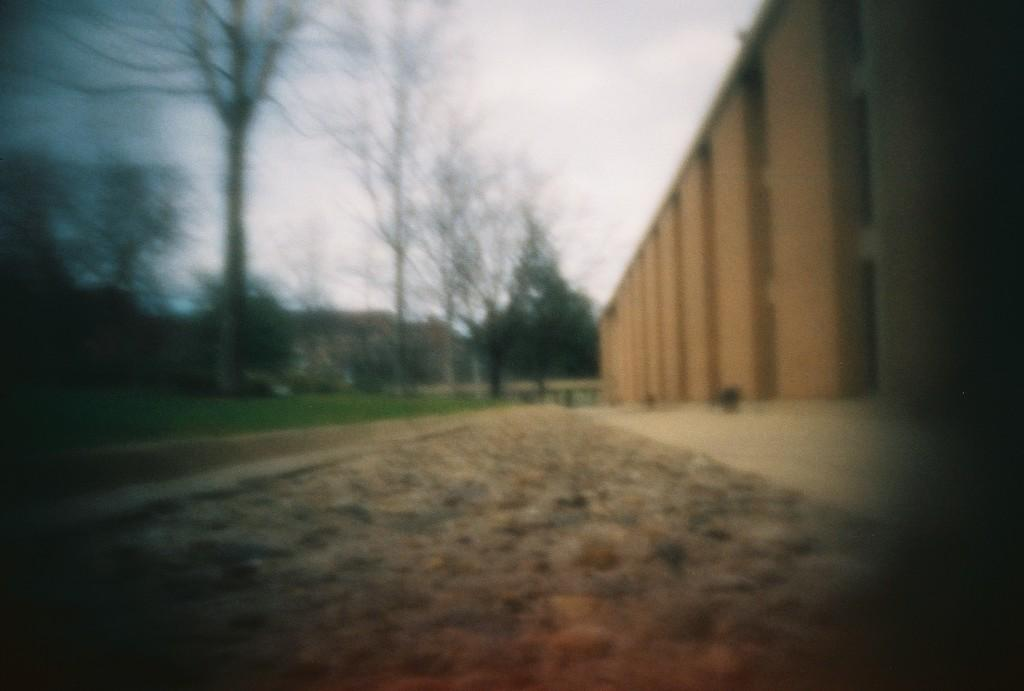What is the main feature of the image? There is a road in the image. What can be seen on the left side of the road? There are many trees on the left side of the image. What is located on the right side of the road? There is a wall on the right side of the image. What type of ink is being used to write on the wall in the image? There is no writing or ink present on the wall in the image. Can you tell me how many teeth are visible on the trees in the image? There are no teeth present on the trees in the image; they are natural vegetation. 